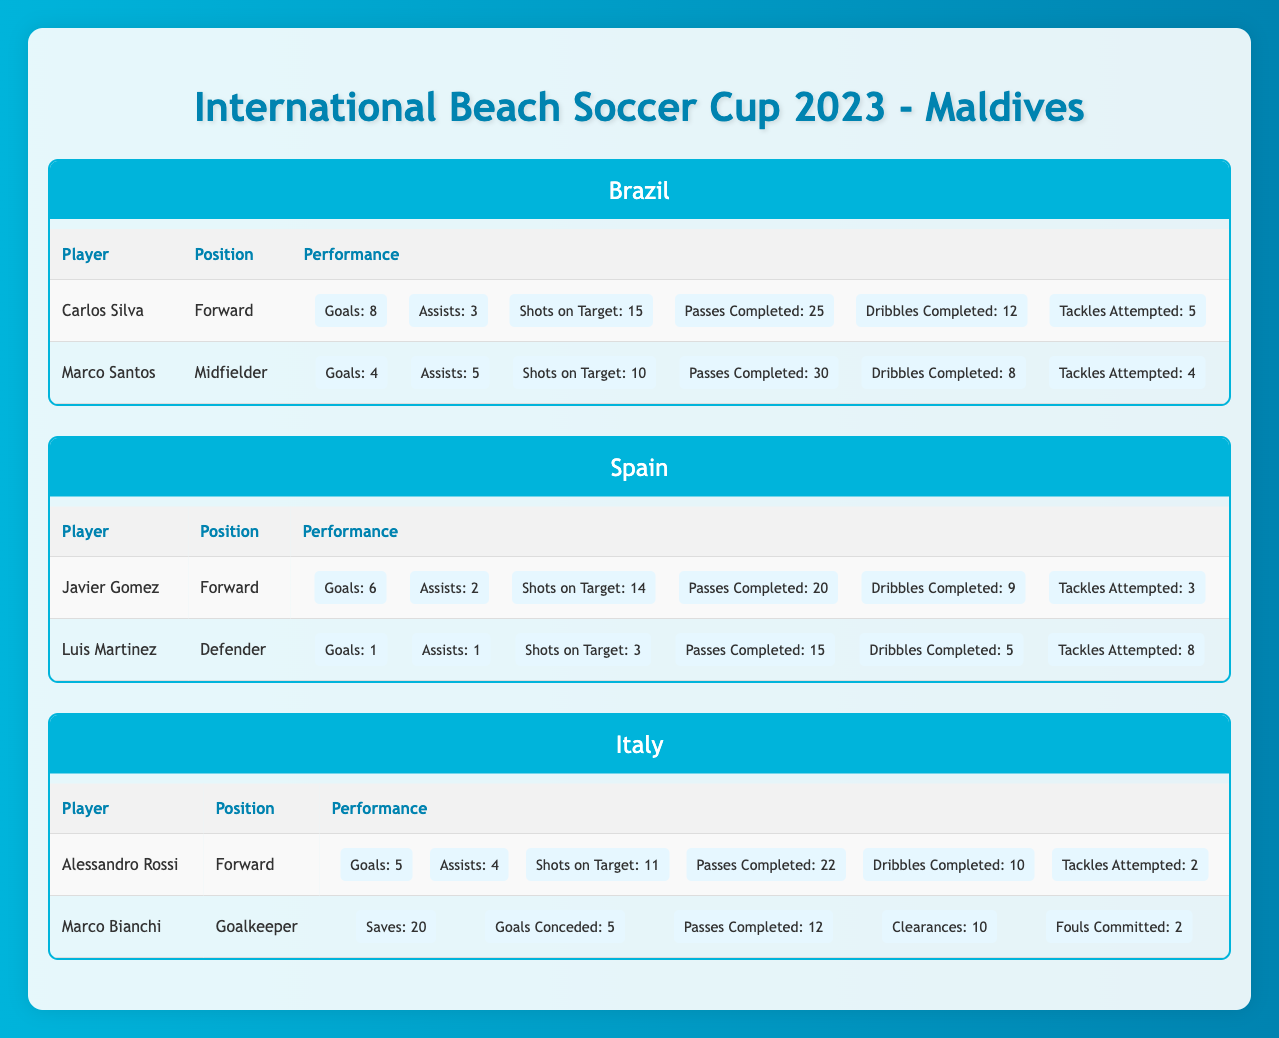What is the highest number of goals scored by a player in the tournament? Carlos Silva scored 8 goals, which is the highest compared to other players. Javier Gomez has 6 goals and Alessandro Rossi has 5 goals, while Marco Santos has 4 and Luis Martinez has 1. Thus, Carlos Silva holds the top position for goals scored.
Answer: 8 Which player has the most assists amongst all teams? Marco Santos has the most assists with 5 assists. Carlos Silva follows with 3 assists. Others have 2 (Javier Gomez), 1 (Luis Martinez), and 4 (Alessandro Rossi) respectively. No other player surpasses Marco Santos in assists.
Answer: 5 How many goals did the defenders score in the tournament? Only one defender, Luis Martinez, scored 1 goal while playing for Spain. Thus, the total goals scored by defenders in the tournament is solely attributed to him.
Answer: 1 If you sum the shots on target for all players in Brazil, what is the total? Carlos Silva had 15 shots on target, and Marco Santos had 10. Therefore, the total for Brazil is 15 + 10 = 25 shots on target.
Answer: 25 Is it true that Italy's goalkeeper conceded fewer goals than saves made? Marco Bianchi, the goalkeeper, conceded 5 goals while making 20 saves. Since 20 is greater than 5, the statement is true.
Answer: Yes Who amongst the forwards had the highest contributions in terms of combined goals and assists? Carlos Silva from Brazil scored 8 goals and had 3 assists for a total of 11 contributions. Javier Gomez has 6 goals and 2 assists, totaling 8 contributions. Alessandro Rossi contributed 9 with 5 goals and 4 assists. Hence, Carlos Silva has the highest combined total.
Answer: Carlos Silva What is the average number of passes completed per player for the team Brazil? The total passes completed by Brazil's players are 25 (Carlos Silva) + 30 (Marco Santos) = 55. There are 2 players, so the average is 55 / 2 = 27.5 passes.
Answer: 27.5 Did any player from Spain complete more passes than any Brazilian player? Marco Santos from Brazil completed 30 passes, while Javier Gomez from Spain completed 20 and Luis Martinez completed 15. Since neither of the Spanish players surpassed 30, the statement is false.
Answer: No What is the difference in goals scored between the top scorer and the second top scorer in the tournament? Carlos Silva scored 8 goals and Javier Gomez scored 6 goals, which gives a difference of 8 - 6 = 2 goals.
Answer: 2 